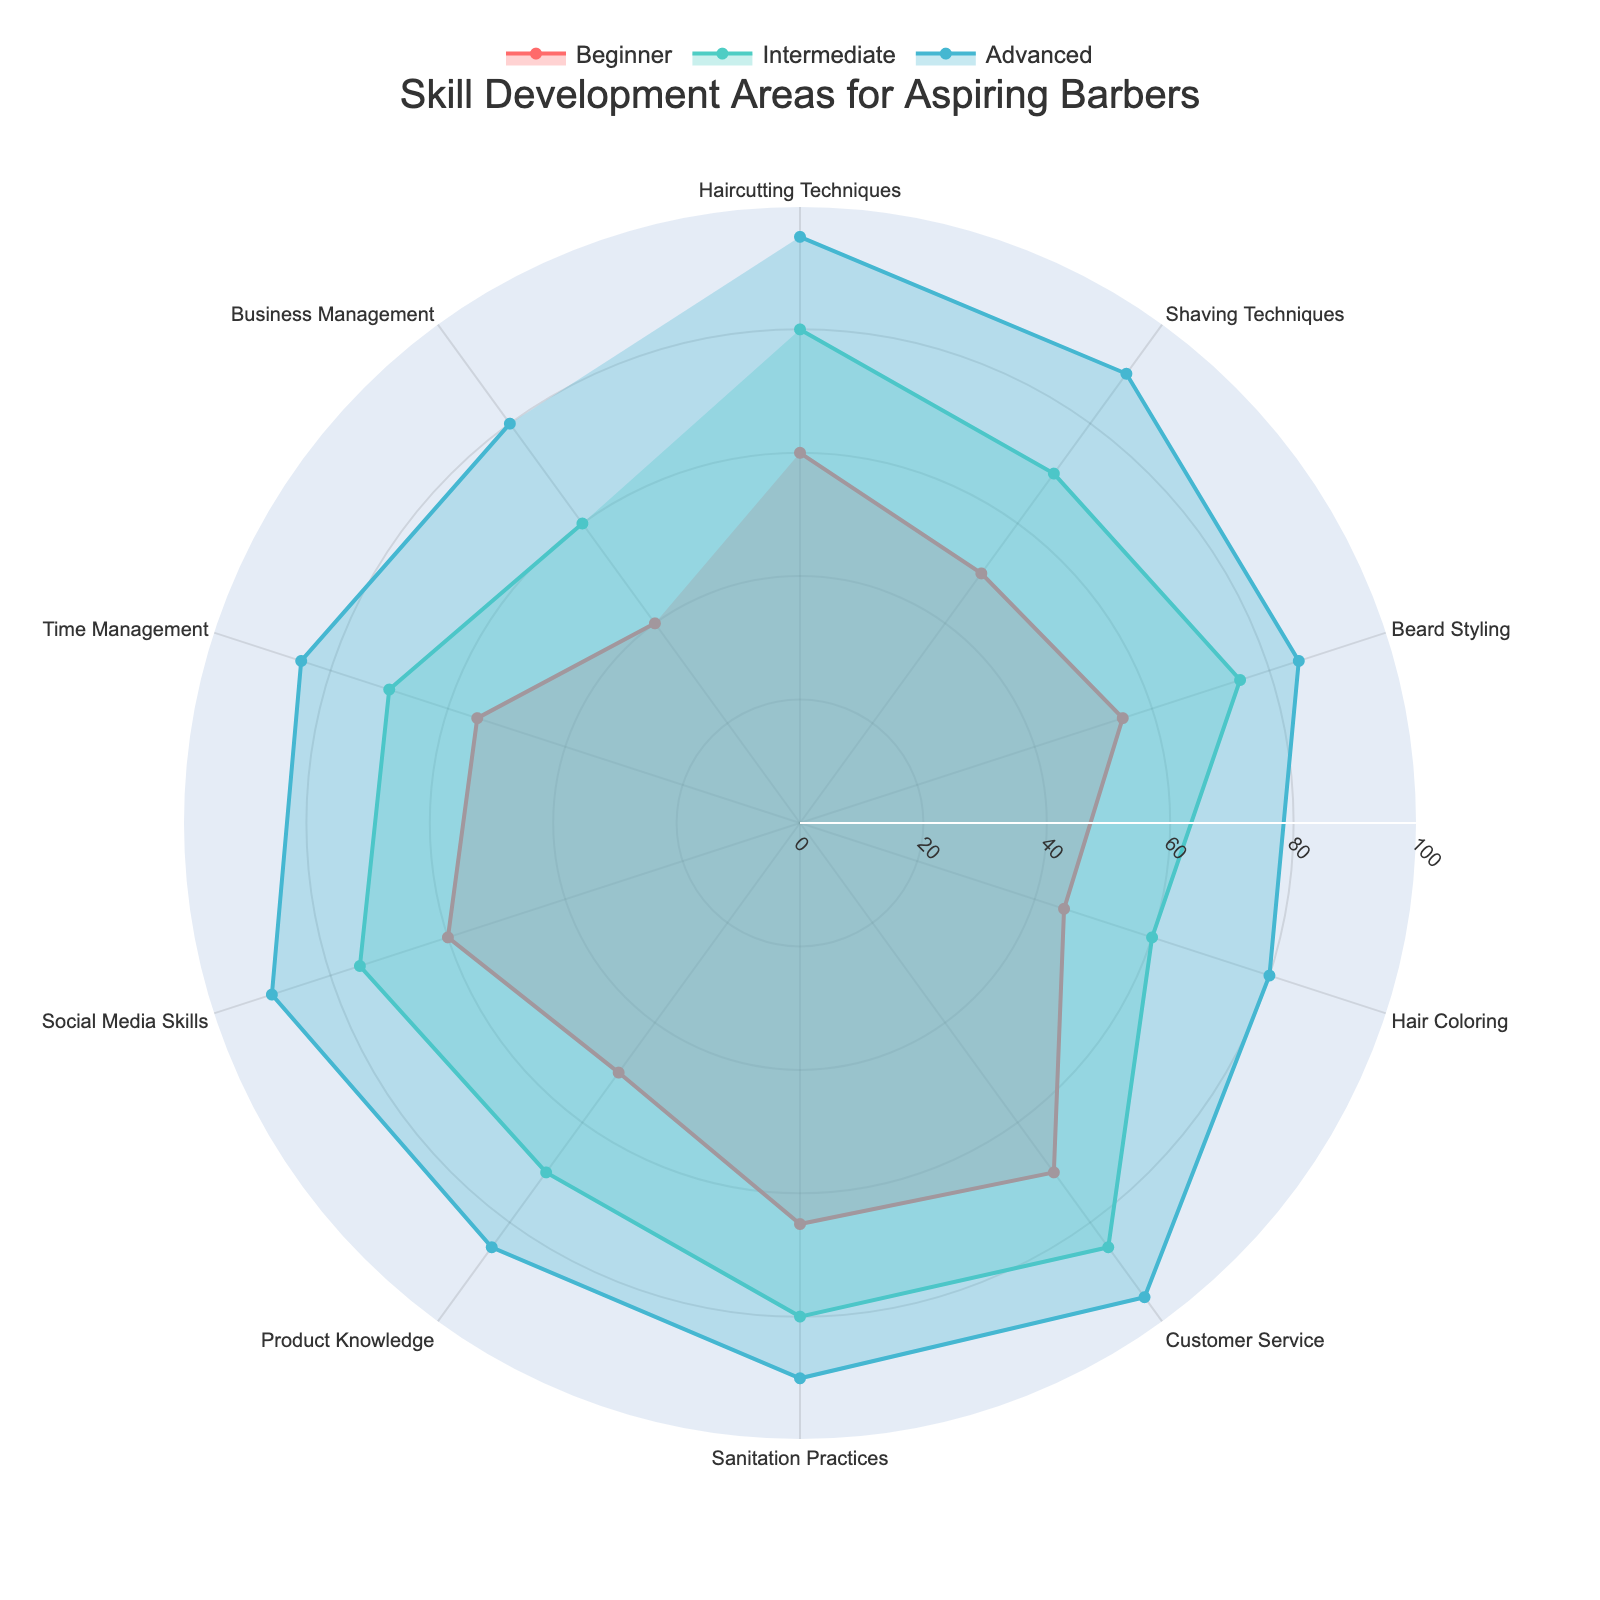What is the title of this chart? The title is located at the top center of the chart, stating what the visualization represents.
Answer: Skill Development Areas for Aspiring Barbers Which skill development area shows the highest score for the Beginner level? At the Beginner level, the skill area with the highest point on the radial axis needs to be identified.
Answer: Customer Service What is the difference in scores for 'Haircutting Techniques' between the Beginner and Advanced levels? Subtract the score of the Beginner level from that of the Advanced level for 'Haircutting Techniques'.
Answer: 35 How do the Intermediate level scores for 'Time Management' and 'Sanitation Practices' compare? Compare the two scores for the Intermediate level by checking the points on the radial axis.
Answer: Sanitation Practices has a higher score Which skill shows the least improvement from the Intermediate to the Advanced level? Calculate the improvement (Advanced score - Intermediate score) for each skill and find the smallest value.
Answer: Hair Coloring Between the Beginner and Intermediate levels, which skill's scores have the smallest increase? Find the differences between Beginner and Intermediate scores for all skills and identify the smallest.
Answer: Hair Coloring How does 'Product Knowledge' at the Advanced level compare to 'Beard Styling' at the Intermediate level? Compare the scores directly by looking at their respective positions on the chart.
Answer: Product Knowledge is higher What is the average score for 'Shaving Techniques' across all levels? Sum the scores for Beginner, Intermediate, and Advanced in 'Shaving Techniques' and divide by 3.
Answer: 70 Are there any skill areas where the Advanced level doesn't reach at least 80? Check each skill's score for the Advanced level to see if any are below 80.
Answer: No In which skill areas do the Beginner and Intermediate levels both have scores above 50? Identify skill areas where both Beginner and Intermediate scores are greater than 50.
Answer: Haircutting Techniques, Beard Styling, Customer Service, Sanitation Practices, Social Media Skills 